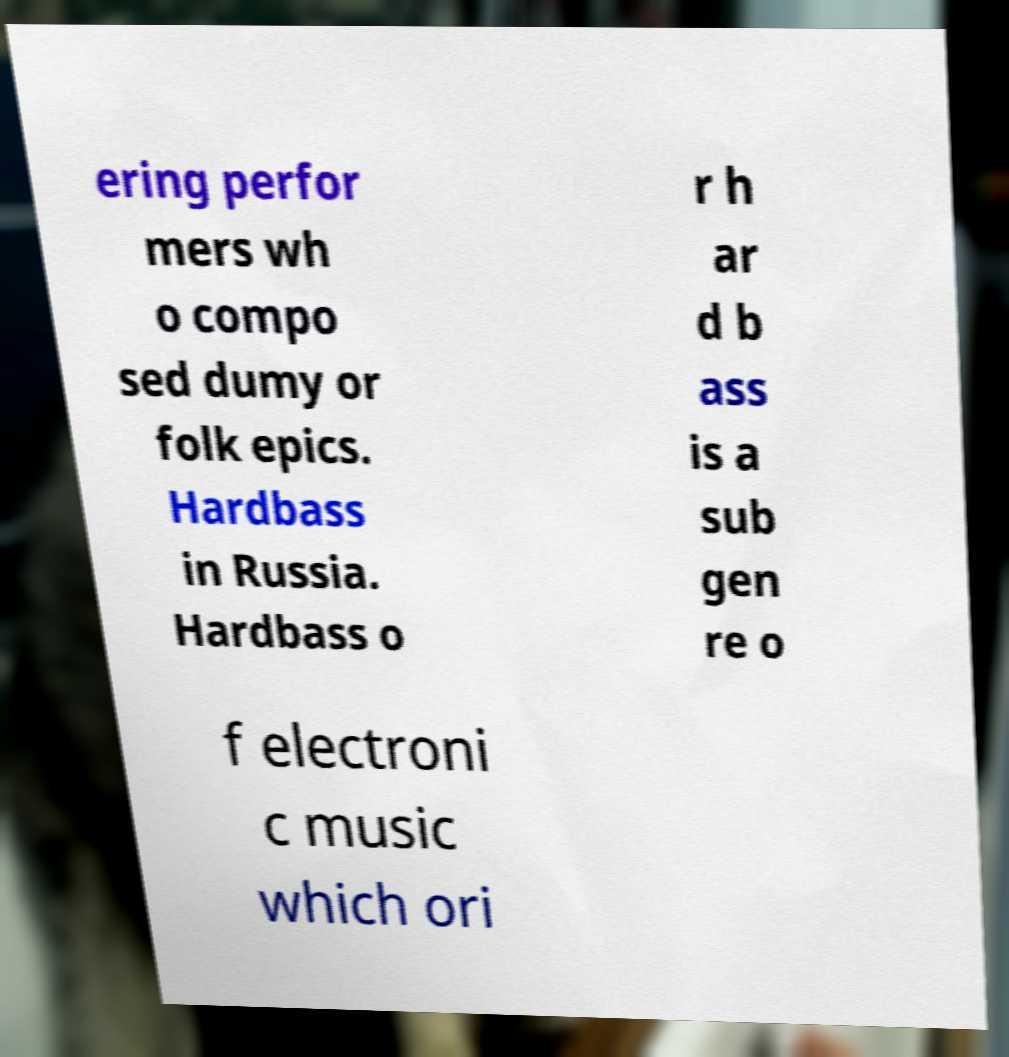Could you extract and type out the text from this image? ering perfor mers wh o compo sed dumy or folk epics. Hardbass in Russia. Hardbass o r h ar d b ass is a sub gen re o f electroni c music which ori 